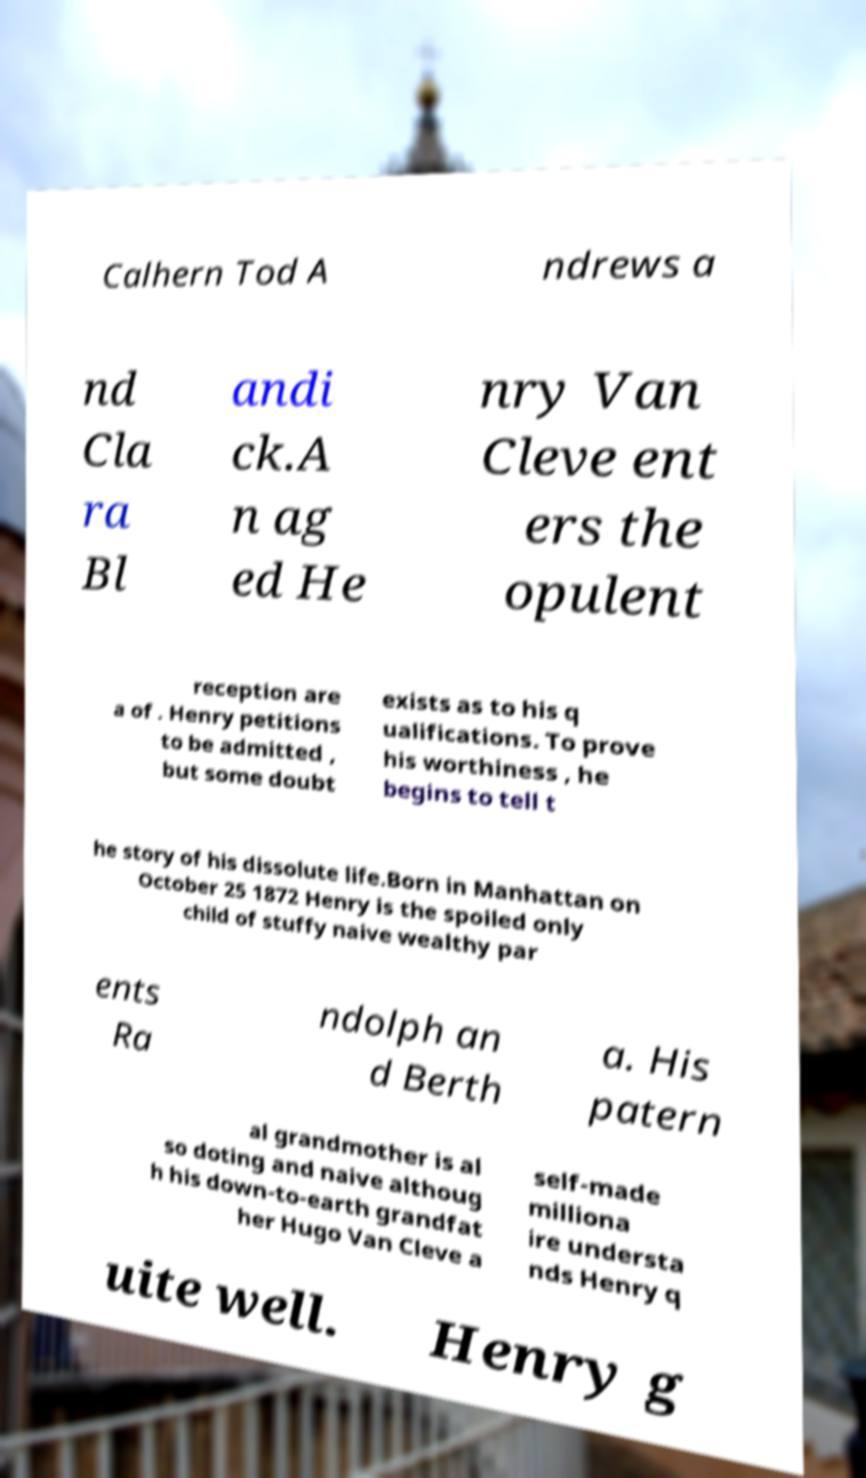For documentation purposes, I need the text within this image transcribed. Could you provide that? Calhern Tod A ndrews a nd Cla ra Bl andi ck.A n ag ed He nry Van Cleve ent ers the opulent reception are a of . Henry petitions to be admitted , but some doubt exists as to his q ualifications. To prove his worthiness , he begins to tell t he story of his dissolute life.Born in Manhattan on October 25 1872 Henry is the spoiled only child of stuffy naive wealthy par ents Ra ndolph an d Berth a. His patern al grandmother is al so doting and naive althoug h his down-to-earth grandfat her Hugo Van Cleve a self-made milliona ire understa nds Henry q uite well. Henry g 